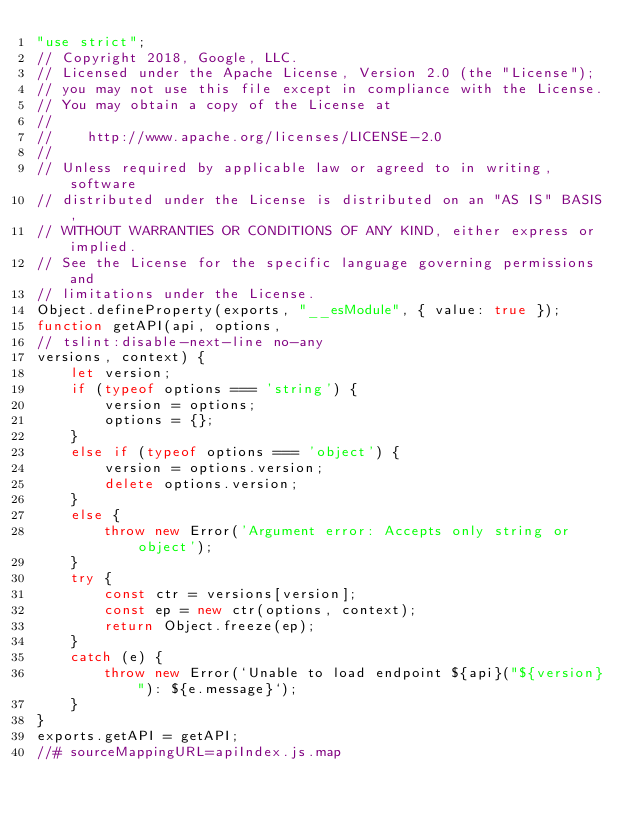<code> <loc_0><loc_0><loc_500><loc_500><_JavaScript_>"use strict";
// Copyright 2018, Google, LLC.
// Licensed under the Apache License, Version 2.0 (the "License");
// you may not use this file except in compliance with the License.
// You may obtain a copy of the License at
//
//    http://www.apache.org/licenses/LICENSE-2.0
//
// Unless required by applicable law or agreed to in writing, software
// distributed under the License is distributed on an "AS IS" BASIS,
// WITHOUT WARRANTIES OR CONDITIONS OF ANY KIND, either express or implied.
// See the License for the specific language governing permissions and
// limitations under the License.
Object.defineProperty(exports, "__esModule", { value: true });
function getAPI(api, options, 
// tslint:disable-next-line no-any
versions, context) {
    let version;
    if (typeof options === 'string') {
        version = options;
        options = {};
    }
    else if (typeof options === 'object') {
        version = options.version;
        delete options.version;
    }
    else {
        throw new Error('Argument error: Accepts only string or object');
    }
    try {
        const ctr = versions[version];
        const ep = new ctr(options, context);
        return Object.freeze(ep);
    }
    catch (e) {
        throw new Error(`Unable to load endpoint ${api}("${version}"): ${e.message}`);
    }
}
exports.getAPI = getAPI;
//# sourceMappingURL=apiIndex.js.map</code> 